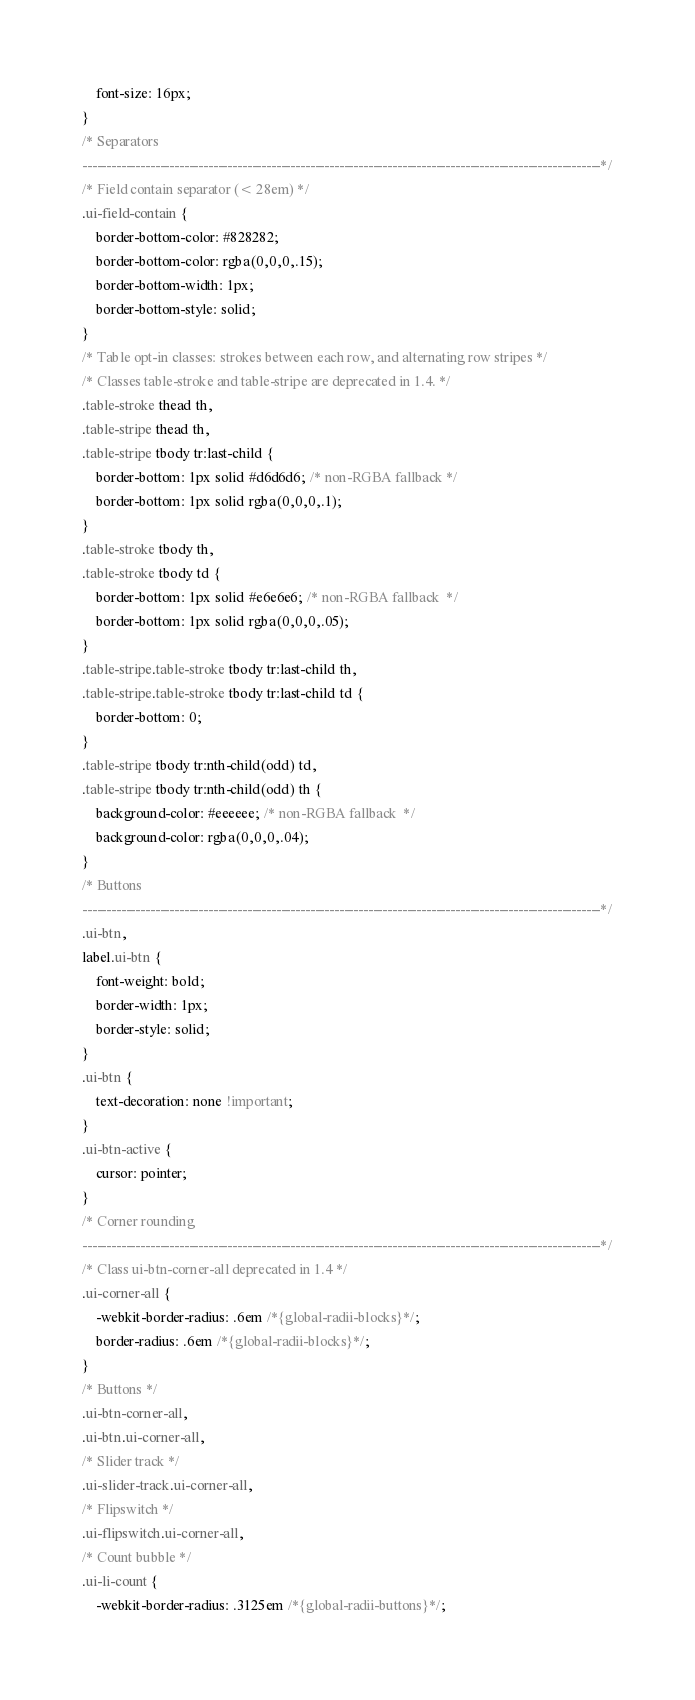<code> <loc_0><loc_0><loc_500><loc_500><_CSS_>	font-size: 16px;
}
/* Separators
-----------------------------------------------------------------------------------------------------------*/
/* Field contain separator (< 28em) */
.ui-field-contain {
	border-bottom-color: #828282;
	border-bottom-color: rgba(0,0,0,.15);
	border-bottom-width: 1px;
	border-bottom-style: solid;
}
/* Table opt-in classes: strokes between each row, and alternating row stripes */
/* Classes table-stroke and table-stripe are deprecated in 1.4. */
.table-stroke thead th,
.table-stripe thead th,
.table-stripe tbody tr:last-child {
	border-bottom: 1px solid #d6d6d6; /* non-RGBA fallback */
	border-bottom: 1px solid rgba(0,0,0,.1);
}
.table-stroke tbody th,
.table-stroke tbody td {
	border-bottom: 1px solid #e6e6e6; /* non-RGBA fallback  */
	border-bottom: 1px solid rgba(0,0,0,.05);
}
.table-stripe.table-stroke tbody tr:last-child th,
.table-stripe.table-stroke tbody tr:last-child td {
	border-bottom: 0;
}
.table-stripe tbody tr:nth-child(odd) td,
.table-stripe tbody tr:nth-child(odd) th {
	background-color: #eeeeee; /* non-RGBA fallback  */
	background-color: rgba(0,0,0,.04);
}
/* Buttons
-----------------------------------------------------------------------------------------------------------*/
.ui-btn,
label.ui-btn {
	font-weight: bold;
	border-width: 1px;
	border-style: solid;
}
.ui-btn {
	text-decoration: none !important;
}
.ui-btn-active {
	cursor: pointer;
}
/* Corner rounding
-----------------------------------------------------------------------------------------------------------*/
/* Class ui-btn-corner-all deprecated in 1.4 */
.ui-corner-all {
	-webkit-border-radius: .6em /*{global-radii-blocks}*/;
	border-radius: .6em /*{global-radii-blocks}*/;
}
/* Buttons */
.ui-btn-corner-all,
.ui-btn.ui-corner-all,
/* Slider track */
.ui-slider-track.ui-corner-all,
/* Flipswitch */
.ui-flipswitch.ui-corner-all,
/* Count bubble */
.ui-li-count {
	-webkit-border-radius: .3125em /*{global-radii-buttons}*/;</code> 